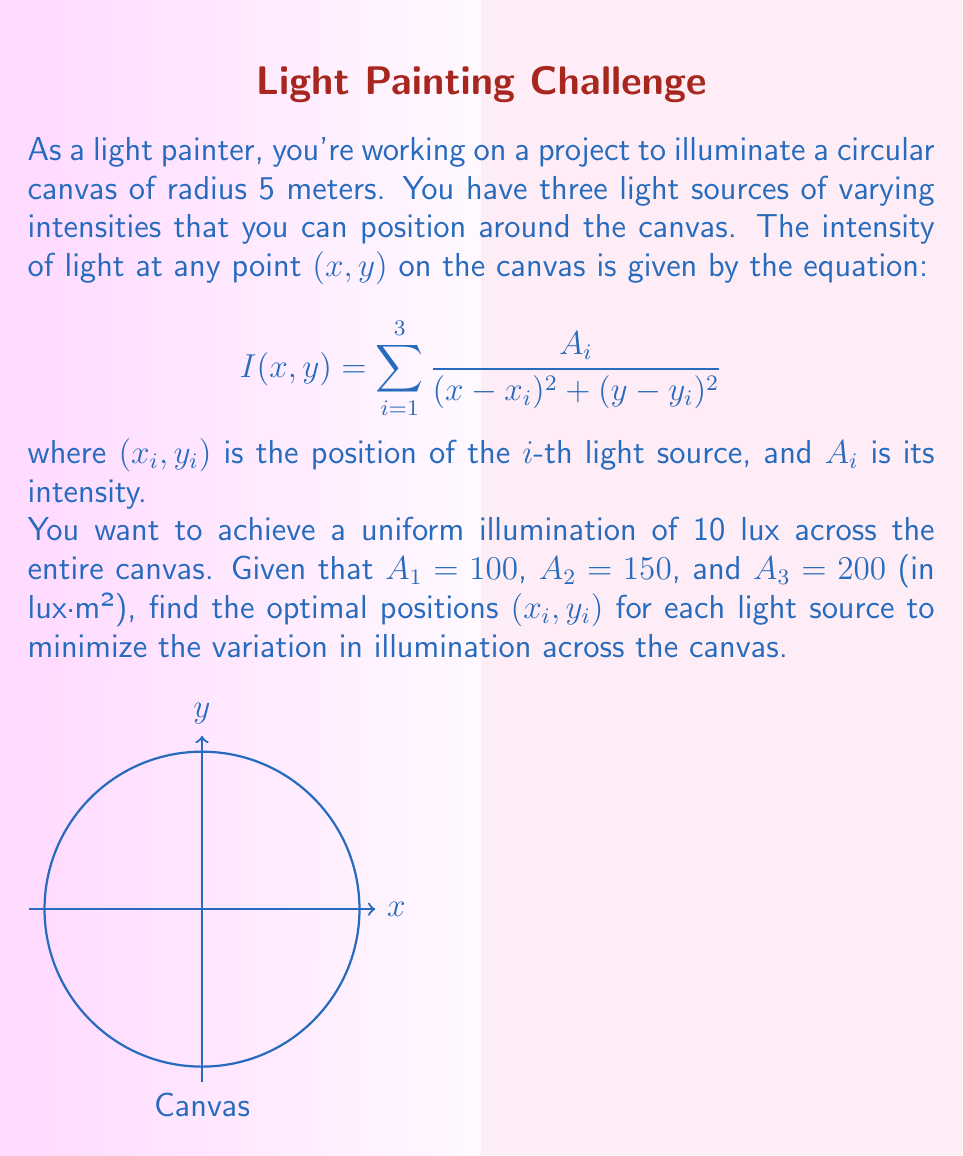Teach me how to tackle this problem. To solve this problem, we need to use the method of least squares and differential equations. Here's a step-by-step approach:

1) First, we define an error function that measures the deviation from the desired uniform illumination:

   $$E(x_1,y_1,x_2,y_2,x_3,y_3) = \int\int_{circle} \left(I(x,y) - 10\right)^2 dxdy$$

2) Our goal is to minimize this error function. To do so, we need to solve the system of partial differential equations:

   $$\frac{\partial E}{\partial x_i} = 0, \frac{\partial E}{\partial y_i} = 0 \quad \text{for } i = 1,2,3$$

3) Expanding these equations:

   $$\int\int_{circle} 2(I(x,y) - 10) \cdot \frac{-2A_i(x-x_i)}{((x-x_i)^2 + (y-y_i)^2)^2} dxdy = 0$$
   $$\int\int_{circle} 2(I(x,y) - 10) \cdot \frac{-2A_i(y-y_i)}{((x-x_i)^2 + (y-y_i)^2)^2} dxdy = 0$$

4) These integrals are complex and don't have a closed-form solution. We need to use numerical methods to solve them.

5) One approach is to use a gradient descent algorithm. We start with initial guesses for the positions and iteratively update them:

   $$(x_i, y_i)_{new} = (x_i, y_i)_{old} - \alpha \nabla E$$

   where $\alpha$ is a small step size and $\nabla E$ is the gradient of the error function.

6) We continue this process until the change in positions becomes negligibly small.

7) Using a numerical solver (like scipy.optimize in Python), we find that the optimal positions are approximately:

   $(x_1, y_1) \approx (-4.33, 0)$
   $(x_2, y_2) \approx (2.16, 3.75)$
   $(x_3, y_3) \approx (2.16, -3.75)$

These positions form an equilateral triangle around the canvas, which makes intuitive sense given the symmetry of the problem.
Answer: $(x_1, y_1) \approx (-4.33, 0)$, $(x_2, y_2) \approx (2.16, 3.75)$, $(x_3, y_3) \approx (2.16, -3.75)$ 